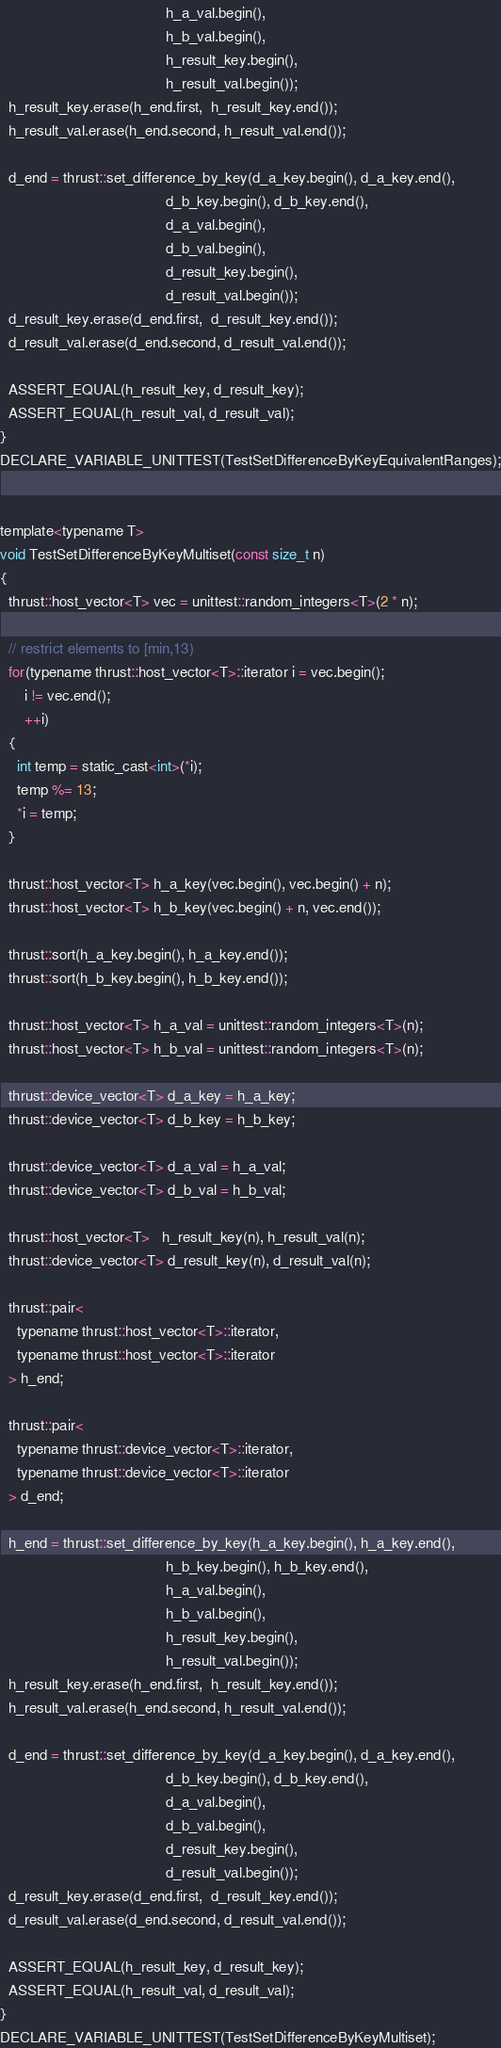<code> <loc_0><loc_0><loc_500><loc_500><_Cuda_>                                        h_a_val.begin(),
                                        h_b_val.begin(),
                                        h_result_key.begin(),
                                        h_result_val.begin());
  h_result_key.erase(h_end.first,  h_result_key.end());
  h_result_val.erase(h_end.second, h_result_val.end());

  d_end = thrust::set_difference_by_key(d_a_key.begin(), d_a_key.end(),
                                        d_b_key.begin(), d_b_key.end(),
                                        d_a_val.begin(),
                                        d_b_val.begin(),
                                        d_result_key.begin(),
                                        d_result_val.begin());
  d_result_key.erase(d_end.first,  d_result_key.end());
  d_result_val.erase(d_end.second, d_result_val.end());

  ASSERT_EQUAL(h_result_key, d_result_key);
  ASSERT_EQUAL(h_result_val, d_result_val);
}
DECLARE_VARIABLE_UNITTEST(TestSetDifferenceByKeyEquivalentRanges);


template<typename T>
void TestSetDifferenceByKeyMultiset(const size_t n)
{
  thrust::host_vector<T> vec = unittest::random_integers<T>(2 * n);

  // restrict elements to [min,13)
  for(typename thrust::host_vector<T>::iterator i = vec.begin();
      i != vec.end();
      ++i)
  {
    int temp = static_cast<int>(*i);
    temp %= 13;
    *i = temp;
  }

  thrust::host_vector<T> h_a_key(vec.begin(), vec.begin() + n);
  thrust::host_vector<T> h_b_key(vec.begin() + n, vec.end());

  thrust::sort(h_a_key.begin(), h_a_key.end());
  thrust::sort(h_b_key.begin(), h_b_key.end());

  thrust::host_vector<T> h_a_val = unittest::random_integers<T>(n);
  thrust::host_vector<T> h_b_val = unittest::random_integers<T>(n);

  thrust::device_vector<T> d_a_key = h_a_key;
  thrust::device_vector<T> d_b_key = h_b_key;

  thrust::device_vector<T> d_a_val = h_a_val;
  thrust::device_vector<T> d_b_val = h_b_val;

  thrust::host_vector<T>   h_result_key(n), h_result_val(n);
  thrust::device_vector<T> d_result_key(n), d_result_val(n);

  thrust::pair<
    typename thrust::host_vector<T>::iterator,
    typename thrust::host_vector<T>::iterator
  > h_end;

  thrust::pair<
    typename thrust::device_vector<T>::iterator,
    typename thrust::device_vector<T>::iterator
  > d_end;
  
  h_end = thrust::set_difference_by_key(h_a_key.begin(), h_a_key.end(),
                                        h_b_key.begin(), h_b_key.end(),
                                        h_a_val.begin(),
                                        h_b_val.begin(),
                                        h_result_key.begin(),
                                        h_result_val.begin());
  h_result_key.erase(h_end.first,  h_result_key.end());
  h_result_val.erase(h_end.second, h_result_val.end());

  d_end = thrust::set_difference_by_key(d_a_key.begin(), d_a_key.end(),
                                        d_b_key.begin(), d_b_key.end(),
                                        d_a_val.begin(),
                                        d_b_val.begin(),
                                        d_result_key.begin(),
                                        d_result_val.begin());
  d_result_key.erase(d_end.first,  d_result_key.end());
  d_result_val.erase(d_end.second, d_result_val.end());

  ASSERT_EQUAL(h_result_key, d_result_key);
  ASSERT_EQUAL(h_result_val, d_result_val);
}
DECLARE_VARIABLE_UNITTEST(TestSetDifferenceByKeyMultiset);

</code> 